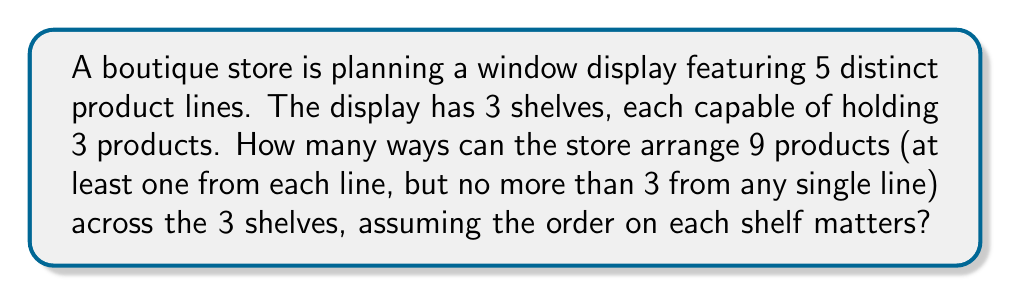Teach me how to tackle this problem. Let's approach this step-by-step:

1) First, we need to determine how many ways we can select 9 products from 5 product lines, with the given constraints:
   - At least one from each line
   - No more than 3 from any single line

   This can be done using the stars and bars method with restrictions. Let's represent it as:
   $$(x_1 + x_2 + x_3 + x_4 + x_5 = 9)$$
   where $1 \leq x_i \leq 3$ for all $i$.

   The number of such distributions is $\binom{9-5+5-1}{5-1} = \binom{8}{4} = 70$

2) Now, for each of these 70 distributions, we need to arrange the products on the shelves.

3) We have 9 distinct positions (3 on each of the 3 shelves), and 9 products to fill them. This is a straightforward permutation:

   $$9! = 362,880$$

4) Therefore, the total number of possible arrangements is:

   $$70 \times 362,880 = 25,401,600$$

This represents all possible ways to select and arrange the products according to the given constraints.
Answer: 25,401,600 